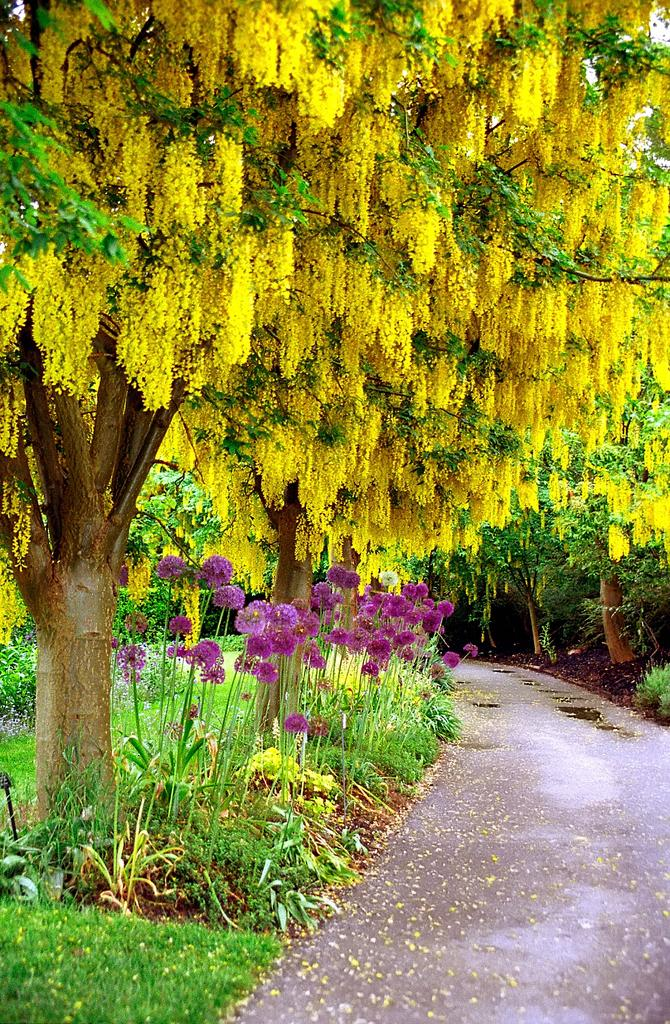What type of flora can be seen in the image? There are flowers in the image. What colors are the flowers? The flowers are in purple and yellow colors. What other natural elements are present in the image? There are trees in the image. What color are the trees? The trees are in green color. Is there a bear combing its fur in the image? No, there is no bear or any combing activity present in the image. 